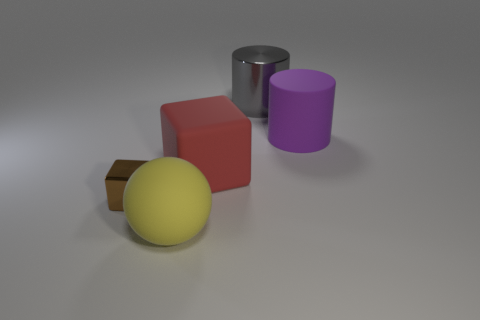Are there any other things that have the same size as the brown object?
Ensure brevity in your answer.  No. What is the material of the big red thing that is right of the yellow matte sphere?
Make the answer very short. Rubber. How many large metallic objects are the same shape as the small brown metal thing?
Give a very brief answer. 0. What material is the object that is left of the big object that is in front of the tiny metallic thing made of?
Provide a short and direct response. Metal. Is there a big gray ball made of the same material as the gray object?
Keep it short and to the point. No. There is a tiny object; what shape is it?
Your answer should be very brief. Cube. What number of green spheres are there?
Offer a very short reply. 0. The big matte object in front of the metal thing on the left side of the large gray cylinder is what color?
Offer a terse response. Yellow. What is the color of the sphere that is the same size as the red rubber thing?
Make the answer very short. Yellow. Are there any cyan objects?
Make the answer very short. No. 